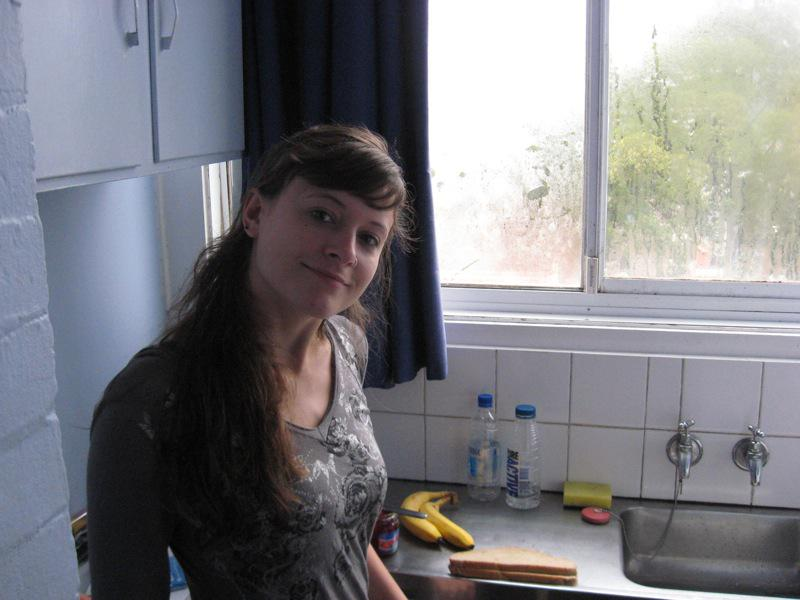Question: what fruit is on the counter?
Choices:
A. Bananas.
B. Oranges.
C. Apples.
D. Pineapples.
Answer with the letter. Answer: A Question: what color is the sponge?
Choices:
A. Blue.
B. Tan.
C. Pink.
D. Yellow.
Answer with the letter. Answer: D Question: how many water spouts are there?
Choices:
A. Three.
B. Two.
C. Four.
D. Five.
Answer with the letter. Answer: B Question: what gender is the person in the photo?
Choices:
A. Male.
B. Transgender.
C. Female.
D. Woman.
Answer with the letter. Answer: C Question: how many cabinets are there?
Choices:
A. Three.
B. Two.
C. Four.
D. Five.
Answer with the letter. Answer: B Question: where is the window?
Choices:
A. In the kitchen.
B. Above the silver sink.
C. Under the awning.
D. In the room.
Answer with the letter. Answer: B Question: what is the girl doing?
Choices:
A. Watching tv.
B. Tilting her head.
C. Jumping on the bed.
D. Listening to music.
Answer with the letter. Answer: B Question: what opens from side to side?
Choices:
A. The windows.
B. Sliding doors.
C. A van door.
D. The window drapes.
Answer with the letter. Answer: A Question: what color is the tile?
Choices:
A. Blue.
B. Black.
C. White.
D. Brown.
Answer with the letter. Answer: C Question: how many bottles are on the counter?
Choices:
A. Three.
B. Four.
C. Five.
D. Two.
Answer with the letter. Answer: D Question: what has handles?
Choices:
A. The cupboard doors.
B. The cabinets.
C. The mugs.
D. The door.
Answer with the letter. Answer: A Question: what color is the cupboard?
Choices:
A. Brown.
B. Red.
C. Blue.
D. White.
Answer with the letter. Answer: D Question: who is going to have a sandwich and two bananas?
Choices:
A. Young man.
B. An elderly woman.
C. An elderly man.
D. Young woman.
Answer with the letter. Answer: D Question: what is in the sink?
Choices:
A. Dirty dishes.
B. A pink stopper.
C. Water.
D. A soapy sponge.
Answer with the letter. Answer: B Question: what is in the window?
Choices:
A. A squirrel.
B. A bird.
C. Flowers.
D. Fog.
Answer with the letter. Answer: D Question: what color is the curtain?
Choices:
A. Pink.
B. Purple.
C. Green.
D. A very dark blue.
Answer with the letter. Answer: D 